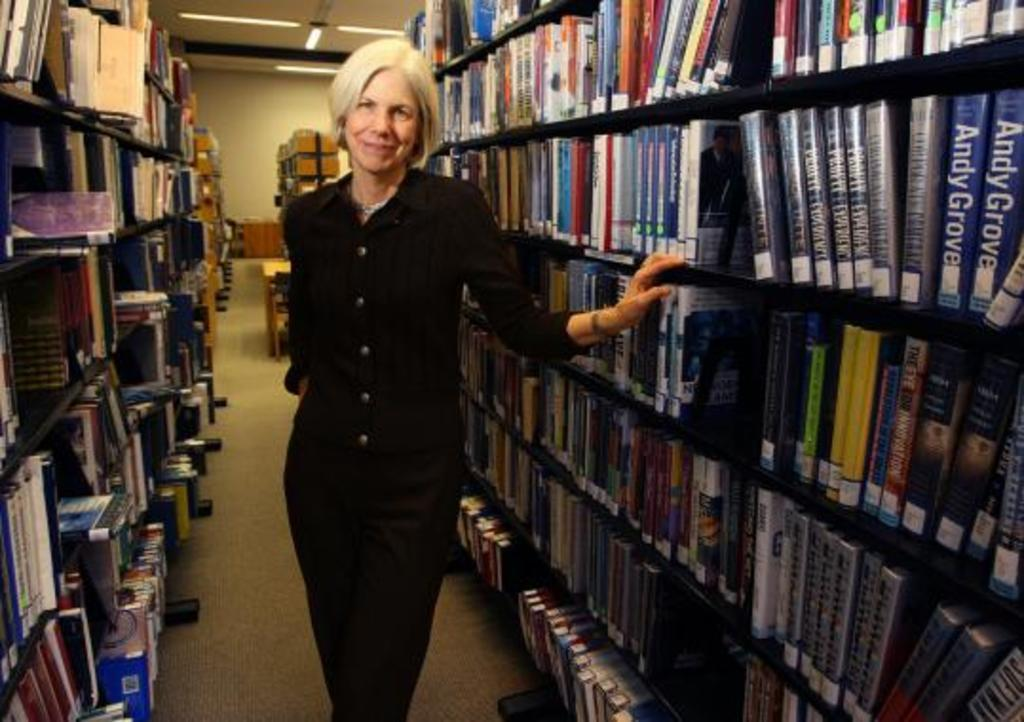<image>
Offer a succinct explanation of the picture presented. several books one that says Andy Grove on it 